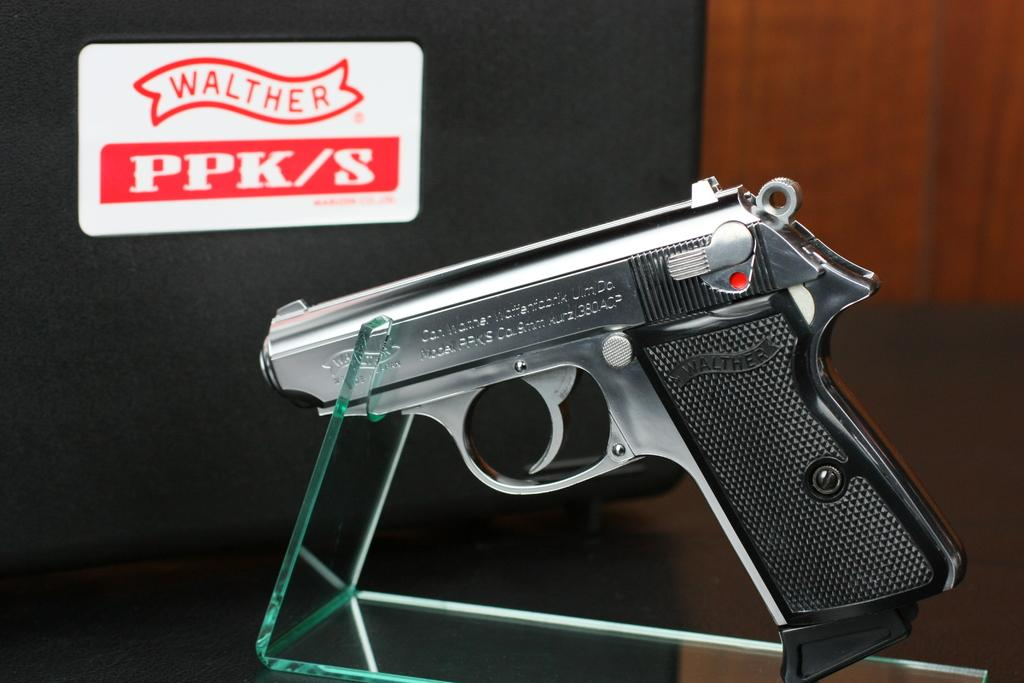What type of gun is in the image? There is a Walther PPK gun in the image. Where is the gun located? The gun is on a table. What else can be seen in the image besides the gun? There is text visible in the image. How many balls are being juggled by the person wearing a mask in the image? There is no person wearing a mask or juggling balls present in the image. 